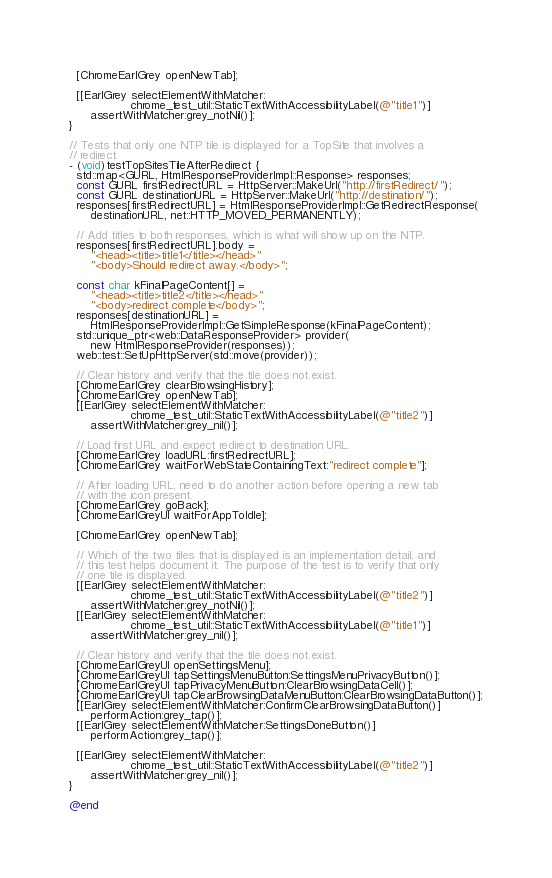Convert code to text. <code><loc_0><loc_0><loc_500><loc_500><_ObjectiveC_>
  [ChromeEarlGrey openNewTab];

  [[EarlGrey selectElementWithMatcher:
                 chrome_test_util::StaticTextWithAccessibilityLabel(@"title1")]
      assertWithMatcher:grey_notNil()];
}

// Tests that only one NTP tile is displayed for a TopSite that involves a
// redirect.
- (void)testTopSitesTileAfterRedirect {
  std::map<GURL, HtmlResponseProviderImpl::Response> responses;
  const GURL firstRedirectURL = HttpServer::MakeUrl("http://firstRedirect/");
  const GURL destinationURL = HttpServer::MakeUrl("http://destination/");
  responses[firstRedirectURL] = HtmlResponseProviderImpl::GetRedirectResponse(
      destinationURL, net::HTTP_MOVED_PERMANENTLY);

  // Add titles to both responses, which is what will show up on the NTP.
  responses[firstRedirectURL].body =
      "<head><title>title1</title></head>"
      "<body>Should redirect away.</body>";

  const char kFinalPageContent[] =
      "<head><title>title2</title></head>"
      "<body>redirect complete</body>";
  responses[destinationURL] =
      HtmlResponseProviderImpl::GetSimpleResponse(kFinalPageContent);
  std::unique_ptr<web::DataResponseProvider> provider(
      new HtmlResponseProvider(responses));
  web::test::SetUpHttpServer(std::move(provider));

  // Clear history and verify that the tile does not exist.
  [ChromeEarlGrey clearBrowsingHistory];
  [ChromeEarlGrey openNewTab];
  [[EarlGrey selectElementWithMatcher:
                 chrome_test_util::StaticTextWithAccessibilityLabel(@"title2")]
      assertWithMatcher:grey_nil()];

  // Load first URL and expect redirect to destination URL.
  [ChromeEarlGrey loadURL:firstRedirectURL];
  [ChromeEarlGrey waitForWebStateContainingText:"redirect complete"];

  // After loading URL, need to do another action before opening a new tab
  // with the icon present.
  [ChromeEarlGrey goBack];
  [ChromeEarlGreyUI waitForAppToIdle];

  [ChromeEarlGrey openNewTab];

  // Which of the two tiles that is displayed is an implementation detail, and
  // this test helps document it. The purpose of the test is to verify that only
  // one tile is displayed.
  [[EarlGrey selectElementWithMatcher:
                 chrome_test_util::StaticTextWithAccessibilityLabel(@"title2")]
      assertWithMatcher:grey_notNil()];
  [[EarlGrey selectElementWithMatcher:
                 chrome_test_util::StaticTextWithAccessibilityLabel(@"title1")]
      assertWithMatcher:grey_nil()];

  // Clear history and verify that the tile does not exist.
  [ChromeEarlGreyUI openSettingsMenu];
  [ChromeEarlGreyUI tapSettingsMenuButton:SettingsMenuPrivacyButton()];
  [ChromeEarlGreyUI tapPrivacyMenuButton:ClearBrowsingDataCell()];
  [ChromeEarlGreyUI tapClearBrowsingDataMenuButton:ClearBrowsingDataButton()];
  [[EarlGrey selectElementWithMatcher:ConfirmClearBrowsingDataButton()]
      performAction:grey_tap()];
  [[EarlGrey selectElementWithMatcher:SettingsDoneButton()]
      performAction:grey_tap()];

  [[EarlGrey selectElementWithMatcher:
                 chrome_test_util::StaticTextWithAccessibilityLabel(@"title2")]
      assertWithMatcher:grey_nil()];
}

@end
</code> 